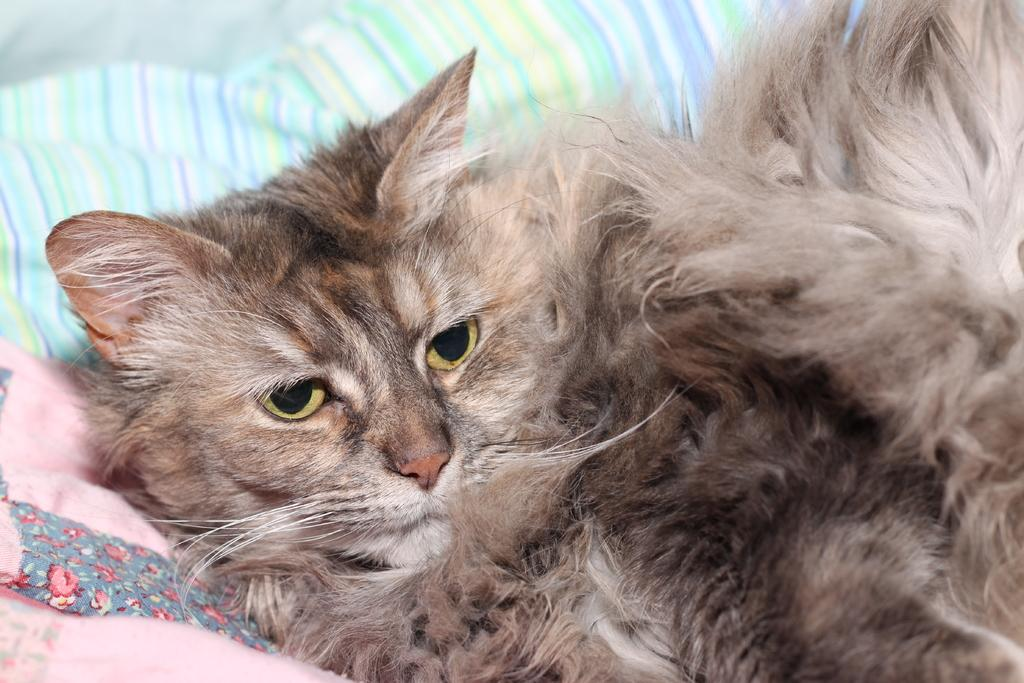What type of animal is in the image? There is a cat in the image. What is the cat doing in the image? The cat is laying on pillows. What type of quartz can be seen on the cat's head in the image? There is no quartz present in the image, and the cat's head is not adorned with any such material. 